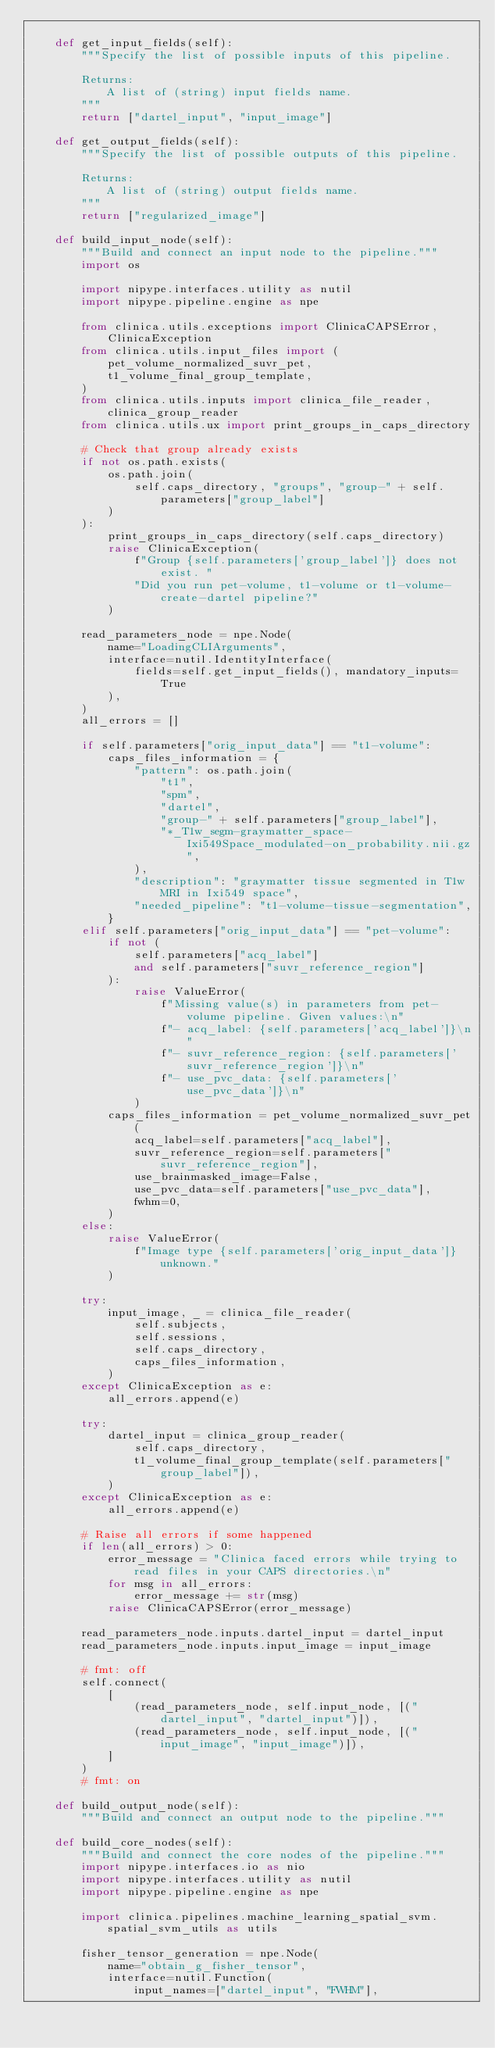<code> <loc_0><loc_0><loc_500><loc_500><_Python_>
    def get_input_fields(self):
        """Specify the list of possible inputs of this pipeline.

        Returns:
            A list of (string) input fields name.
        """
        return ["dartel_input", "input_image"]

    def get_output_fields(self):
        """Specify the list of possible outputs of this pipeline.

        Returns:
            A list of (string) output fields name.
        """
        return ["regularized_image"]

    def build_input_node(self):
        """Build and connect an input node to the pipeline."""
        import os

        import nipype.interfaces.utility as nutil
        import nipype.pipeline.engine as npe

        from clinica.utils.exceptions import ClinicaCAPSError, ClinicaException
        from clinica.utils.input_files import (
            pet_volume_normalized_suvr_pet,
            t1_volume_final_group_template,
        )
        from clinica.utils.inputs import clinica_file_reader, clinica_group_reader
        from clinica.utils.ux import print_groups_in_caps_directory

        # Check that group already exists
        if not os.path.exists(
            os.path.join(
                self.caps_directory, "groups", "group-" + self.parameters["group_label"]
            )
        ):
            print_groups_in_caps_directory(self.caps_directory)
            raise ClinicaException(
                f"Group {self.parameters['group_label']} does not exist. "
                "Did you run pet-volume, t1-volume or t1-volume-create-dartel pipeline?"
            )

        read_parameters_node = npe.Node(
            name="LoadingCLIArguments",
            interface=nutil.IdentityInterface(
                fields=self.get_input_fields(), mandatory_inputs=True
            ),
        )
        all_errors = []

        if self.parameters["orig_input_data"] == "t1-volume":
            caps_files_information = {
                "pattern": os.path.join(
                    "t1",
                    "spm",
                    "dartel",
                    "group-" + self.parameters["group_label"],
                    "*_T1w_segm-graymatter_space-Ixi549Space_modulated-on_probability.nii.gz",
                ),
                "description": "graymatter tissue segmented in T1w MRI in Ixi549 space",
                "needed_pipeline": "t1-volume-tissue-segmentation",
            }
        elif self.parameters["orig_input_data"] == "pet-volume":
            if not (
                self.parameters["acq_label"]
                and self.parameters["suvr_reference_region"]
            ):
                raise ValueError(
                    f"Missing value(s) in parameters from pet-volume pipeline. Given values:\n"
                    f"- acq_label: {self.parameters['acq_label']}\n"
                    f"- suvr_reference_region: {self.parameters['suvr_reference_region']}\n"
                    f"- use_pvc_data: {self.parameters['use_pvc_data']}\n"
                )
            caps_files_information = pet_volume_normalized_suvr_pet(
                acq_label=self.parameters["acq_label"],
                suvr_reference_region=self.parameters["suvr_reference_region"],
                use_brainmasked_image=False,
                use_pvc_data=self.parameters["use_pvc_data"],
                fwhm=0,
            )
        else:
            raise ValueError(
                f"Image type {self.parameters['orig_input_data']} unknown."
            )

        try:
            input_image, _ = clinica_file_reader(
                self.subjects,
                self.sessions,
                self.caps_directory,
                caps_files_information,
            )
        except ClinicaException as e:
            all_errors.append(e)

        try:
            dartel_input = clinica_group_reader(
                self.caps_directory,
                t1_volume_final_group_template(self.parameters["group_label"]),
            )
        except ClinicaException as e:
            all_errors.append(e)

        # Raise all errors if some happened
        if len(all_errors) > 0:
            error_message = "Clinica faced errors while trying to read files in your CAPS directories.\n"
            for msg in all_errors:
                error_message += str(msg)
            raise ClinicaCAPSError(error_message)

        read_parameters_node.inputs.dartel_input = dartel_input
        read_parameters_node.inputs.input_image = input_image

        # fmt: off
        self.connect(
            [
                (read_parameters_node, self.input_node, [("dartel_input", "dartel_input")]),
                (read_parameters_node, self.input_node, [("input_image", "input_image")]),
            ]
        )
        # fmt: on

    def build_output_node(self):
        """Build and connect an output node to the pipeline."""

    def build_core_nodes(self):
        """Build and connect the core nodes of the pipeline."""
        import nipype.interfaces.io as nio
        import nipype.interfaces.utility as nutil
        import nipype.pipeline.engine as npe

        import clinica.pipelines.machine_learning_spatial_svm.spatial_svm_utils as utils

        fisher_tensor_generation = npe.Node(
            name="obtain_g_fisher_tensor",
            interface=nutil.Function(
                input_names=["dartel_input", "FWHM"],</code> 